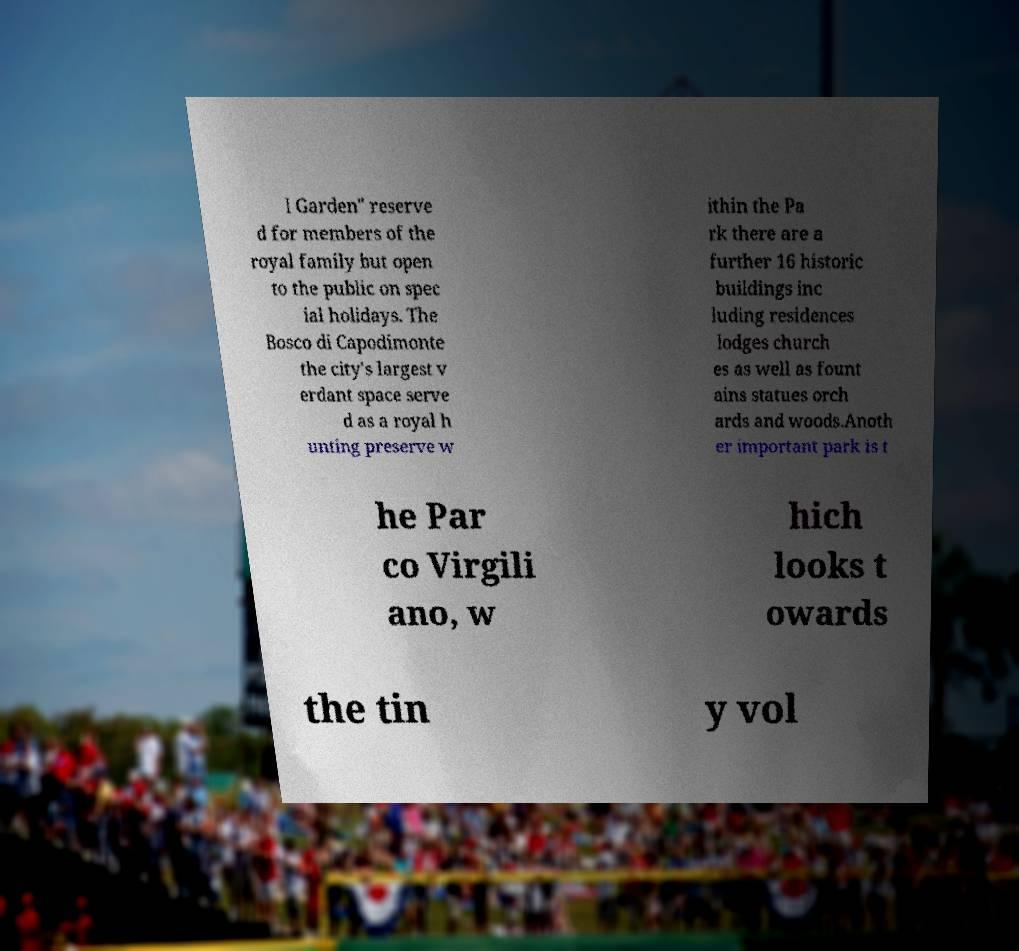Could you extract and type out the text from this image? l Garden" reserve d for members of the royal family but open to the public on spec ial holidays. The Bosco di Capodimonte the city's largest v erdant space serve d as a royal h unting preserve w ithin the Pa rk there are a further 16 historic buildings inc luding residences lodges church es as well as fount ains statues orch ards and woods.Anoth er important park is t he Par co Virgili ano, w hich looks t owards the tin y vol 